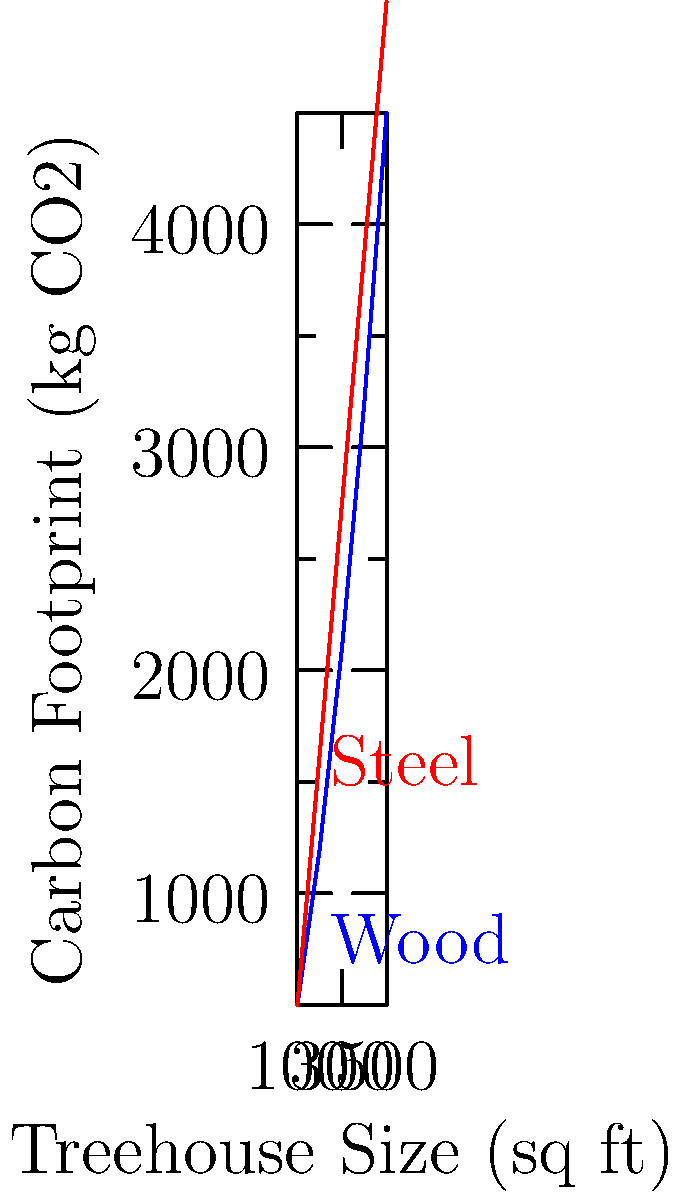Based on the graph showing the relationship between treehouse size and carbon footprint for wood and steel constructions, estimate the difference in carbon footprint (in kg CO2) between a 350 sq ft treehouse built primarily with wood versus one built primarily with steel. To solve this problem, we'll follow these steps:

1. Identify the carbon footprint for a 350 sq ft wood treehouse:
   - Locate 350 sq ft on the x-axis
   - Find the corresponding point on the blue (wood) line
   - Read the y-value: approximately 2650 kg CO2

2. Identify the carbon footprint for a 350 sq ft steel treehouse:
   - Locate 350 sq ft on the x-axis
   - Find the corresponding point on the red (steel) line
   - Read the y-value: approximately 3750 kg CO2

3. Calculate the difference:
   $$ \text{Difference} = \text{Steel footprint} - \text{Wood footprint} $$
   $$ \text{Difference} = 3750 \text{ kg CO2} - 2650 \text{ kg CO2} = 1100 \text{ kg CO2} $$

Therefore, the difference in carbon footprint between a 350 sq ft treehouse built with steel versus wood is approximately 1100 kg CO2.
Answer: 1100 kg CO2 